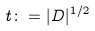<formula> <loc_0><loc_0><loc_500><loc_500>t \colon = | D | ^ { 1 / 2 }</formula> 